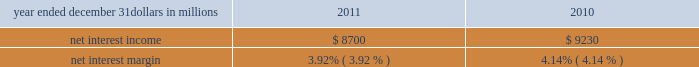Corporate & institutional banking corporate & institutional banking earned $ 1.9 billion in 2011 and $ 1.8 billion in 2010 .
The increase in earnings was primarily due to an improvement in the provision for credit losses , which was a benefit in 2011 , partially offset by a reduction in the value of commercial mortgage servicing rights and lower net interest income .
We continued to focus on adding new clients , increasing cross sales , and remaining committed to strong expense discipline .
Asset management group asset management group earned $ 141 million for 2011 compared with $ 137 million for 2010 .
Assets under administration were $ 210 billion at december 31 , 2011 and $ 212 billion at december 31 , 2010 .
Earnings for 2011 reflected a benefit from the provision for credit losses and growth in noninterest income , partially offset by higher noninterest expense and lower net interest income .
For 2011 , the business delivered strong sales production , grew high value clients and benefitted from significant referrals from other pnc lines of business .
Over time and with stabilized market conditions , the successful execution of these strategies and the accumulation of our strong sales performance are expected to create meaningful growth in assets under management and noninterest income .
Residential mortgage banking residential mortgage banking earned $ 87 million in 2011 compared with $ 269 million in 2010 .
The decline in earnings was driven by an increase in noninterest expense associated with increased costs for residential mortgage foreclosure- related expenses , primarily as a result of ongoing governmental matters , and lower net interest income , partially offset by an increase in loan originations and higher loans sales revenue .
Blackrock our blackrock business segment earned $ 361 million in 2011 and $ 351 million in 2010 .
The higher business segment earnings from blackrock for 2011 compared with 2010 were primarily due to an increase in revenue .
Non-strategic assets portfolio this business segment ( formerly distressed assets portfolio ) consists primarily of acquired non-strategic assets that fall outside of our core business strategy .
Non-strategic assets portfolio had earnings of $ 200 million in 2011 compared with a loss of $ 57 million in 2010 .
The increase was primarily attributable to a lower provision for credit losses partially offset by lower net interest income .
201cother 201d reported earnings of $ 376 million for 2011 compared with earnings of $ 386 million for 2010 .
The decrease in earnings primarily reflected the noncash charge related to the redemption of trust preferred securities in the fourth quarter of 2011 and the gain related to the sale of a portion of pnc 2019s blackrock shares in 2010 partially offset by lower integration costs in 2011 .
Consolidated income statement review our consolidated income statement is presented in item 8 of this report .
Net income for 2011 was $ 3.1 billion compared with $ 3.4 billion for 2010 .
Results for 2011 include the impact of $ 324 million of residential mortgage foreclosure-related expenses primarily as a result of ongoing governmental matters , a $ 198 million noncash charge related to redemption of trust preferred securities and $ 42 million for integration costs .
Results for 2010 included the $ 328 million after-tax gain on our sale of gis , $ 387 million for integration costs , and $ 71 million of residential mortgage foreclosure-related expenses .
For 2010 , net income attributable to common shareholders was also impacted by a noncash reduction of $ 250 million in connection with the redemption of tarp preferred stock .
Pnc 2019s results for 2011 were driven by good performance in a challenging environment of low interest rates , slow economic growth and new regulations .
Net interest income and net interest margin year ended december 31 dollars in millions 2011 2010 .
Changes in net interest income and margin result from the interaction of the volume and composition of interest-earning assets and related yields , interest-bearing liabilities and related rates paid , and noninterest-bearing sources of funding .
See the statistical information ( unaudited ) 2013 analysis of year-to-year changes in net interest income and average consolidated balance sheet and net interest analysis in item 8 and the discussion of purchase accounting accretion in the consolidated balance sheet review in item 7 of this report for additional information .
The decreases in net interest income and net interest margin for 2011 compared with 2010 were primarily attributable to a decrease in purchase accounting accretion on purchased impaired loans primarily due to lower excess cash recoveries .
A decline in average loan balances and the low interest rate environment , partially offset by lower funding costs , also contributed to the decrease .
The pnc financial services group , inc .
2013 form 10-k 35 .
For 2010 was the noncash expense in connection with the redemption of tarp preferred stock less than total net interest income? 
Computations: (250 > 9230)
Answer: no. 